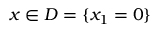Convert formula to latex. <formula><loc_0><loc_0><loc_500><loc_500>x \in D = \{ x _ { 1 } = 0 \}</formula> 